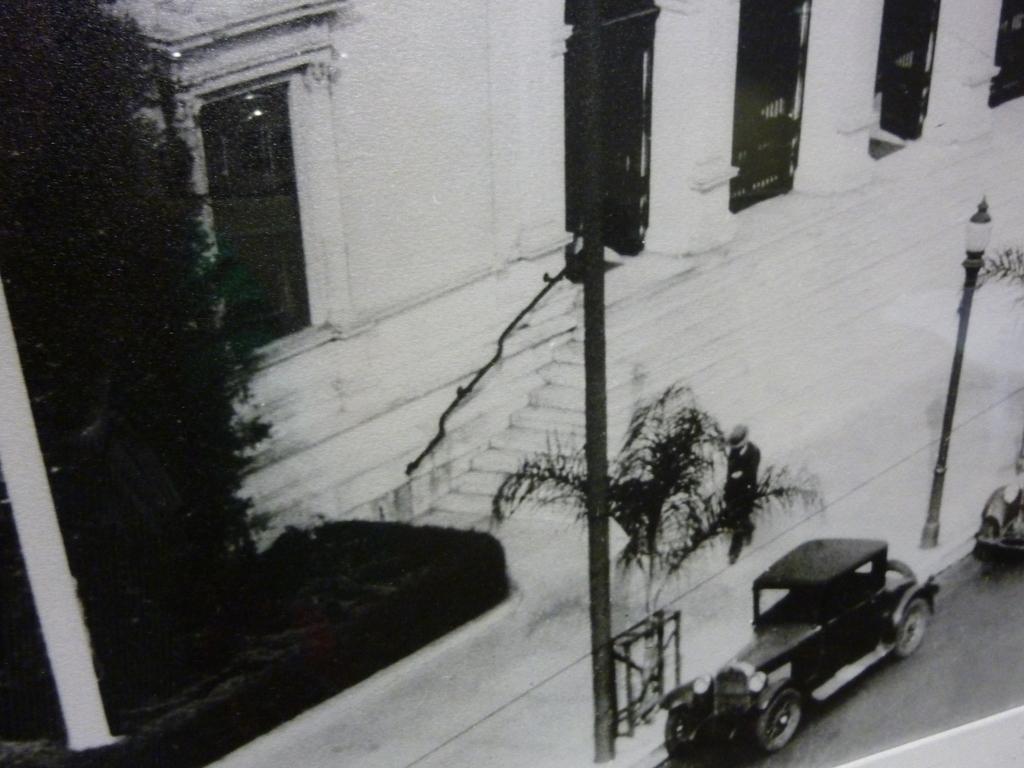Can you describe this image briefly? In this picture we can see vehicles on the road, poles, plants and in the background we can see a building with a window, steps. 